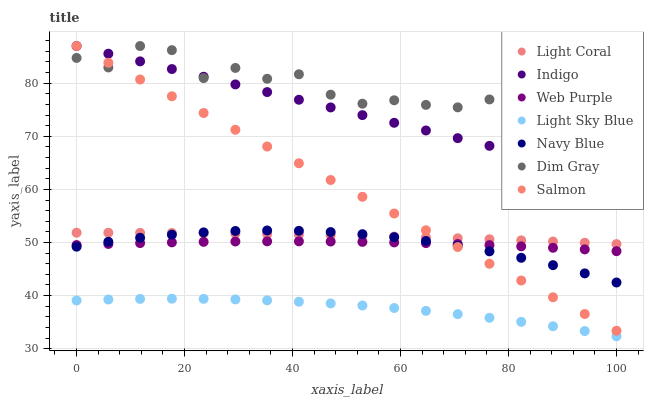Does Light Sky Blue have the minimum area under the curve?
Answer yes or no. Yes. Does Dim Gray have the maximum area under the curve?
Answer yes or no. Yes. Does Indigo have the minimum area under the curve?
Answer yes or no. No. Does Indigo have the maximum area under the curve?
Answer yes or no. No. Is Salmon the smoothest?
Answer yes or no. Yes. Is Dim Gray the roughest?
Answer yes or no. Yes. Is Indigo the smoothest?
Answer yes or no. No. Is Indigo the roughest?
Answer yes or no. No. Does Light Sky Blue have the lowest value?
Answer yes or no. Yes. Does Indigo have the lowest value?
Answer yes or no. No. Does Salmon have the highest value?
Answer yes or no. Yes. Does Navy Blue have the highest value?
Answer yes or no. No. Is Web Purple less than Dim Gray?
Answer yes or no. Yes. Is Dim Gray greater than Navy Blue?
Answer yes or no. Yes. Does Navy Blue intersect Web Purple?
Answer yes or no. Yes. Is Navy Blue less than Web Purple?
Answer yes or no. No. Is Navy Blue greater than Web Purple?
Answer yes or no. No. Does Web Purple intersect Dim Gray?
Answer yes or no. No. 